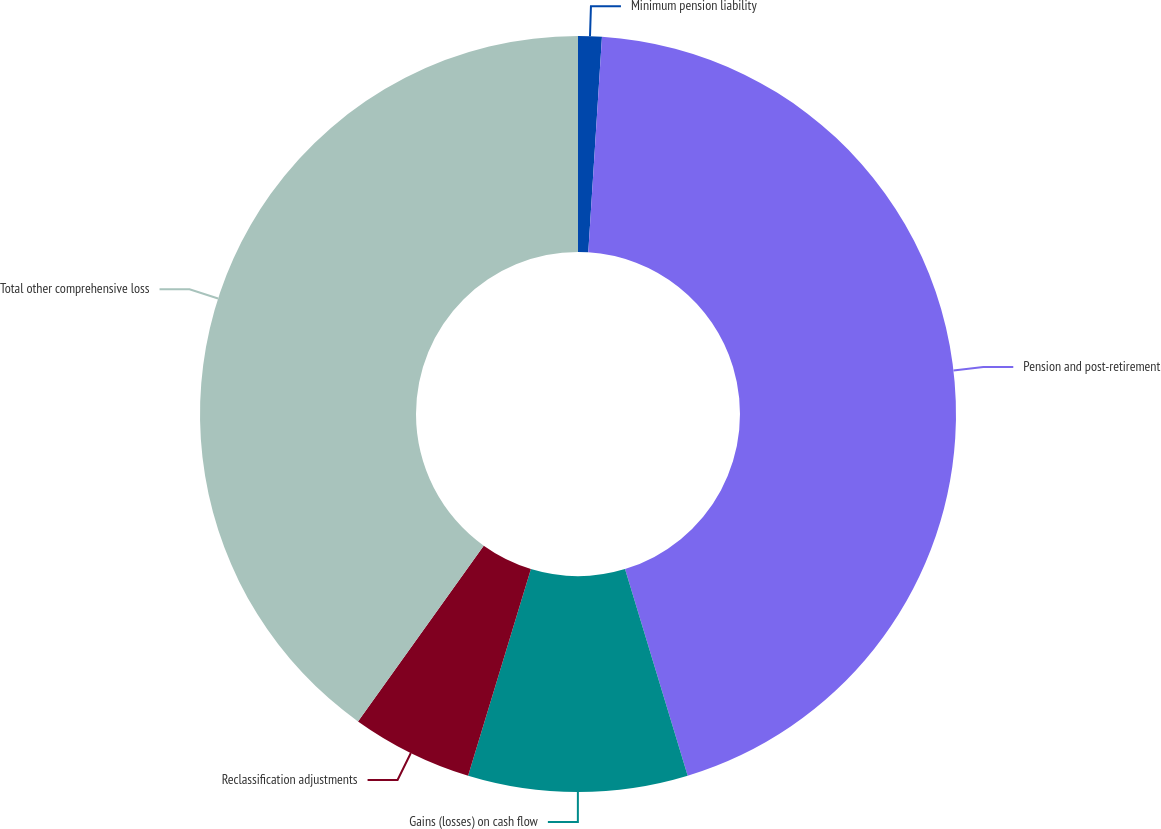<chart> <loc_0><loc_0><loc_500><loc_500><pie_chart><fcel>Minimum pension liability<fcel>Pension and post-retirement<fcel>Gains (losses) on cash flow<fcel>Reclassification adjustments<fcel>Total other comprehensive loss<nl><fcel>1.01%<fcel>44.3%<fcel>9.38%<fcel>5.19%<fcel>40.11%<nl></chart> 